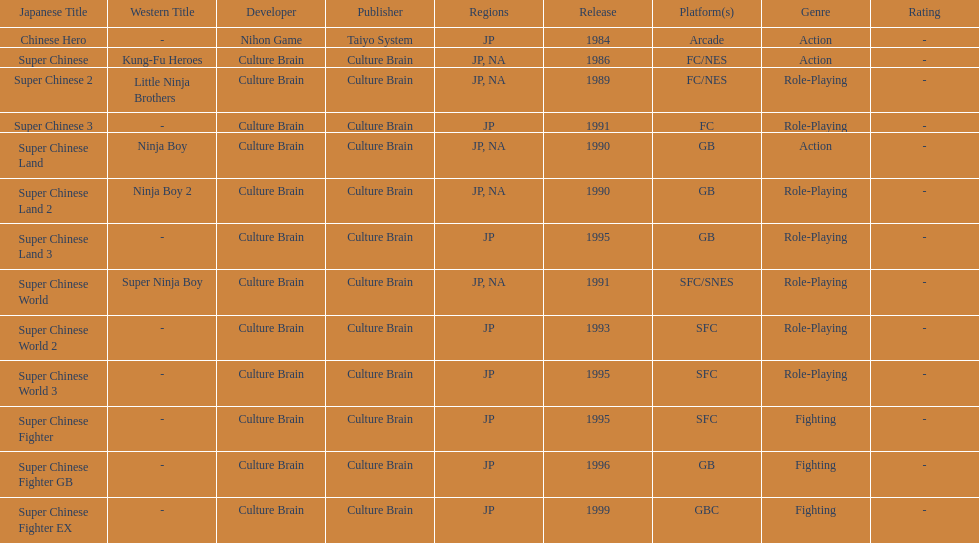When was the last super chinese game released? 1999. 